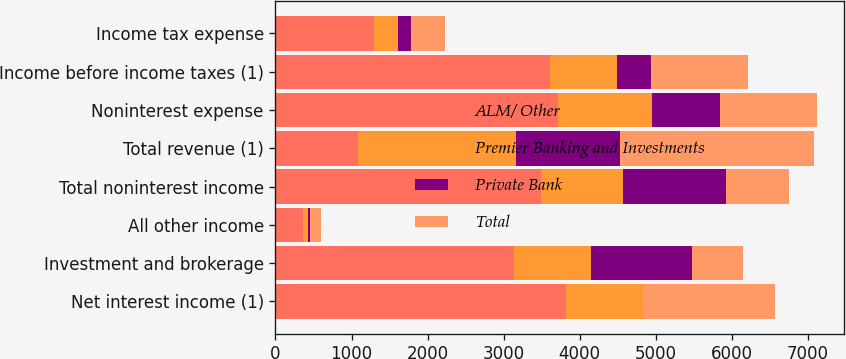<chart> <loc_0><loc_0><loc_500><loc_500><stacked_bar_chart><ecel><fcel>Net interest income (1)<fcel>Investment and brokerage<fcel>All other income<fcel>Total noninterest income<fcel>Total revenue (1)<fcel>Noninterest expense<fcel>Income before income taxes (1)<fcel>Income tax expense<nl><fcel>ALM/ Other<fcel>3820<fcel>3140<fcel>356<fcel>3496<fcel>1079<fcel>3710<fcel>3613<fcel>1297<nl><fcel>Premier Banking and Investments<fcel>1008<fcel>1014<fcel>65<fcel>1079<fcel>2087<fcel>1237<fcel>873<fcel>314<nl><fcel>Private Bank<fcel>6<fcel>1321<fcel>32<fcel>1353<fcel>1359<fcel>902<fcel>457<fcel>165<nl><fcel>Total<fcel>1732<fcel>670<fcel>148<fcel>818<fcel>2550<fcel>1266<fcel>1266<fcel>456<nl></chart> 